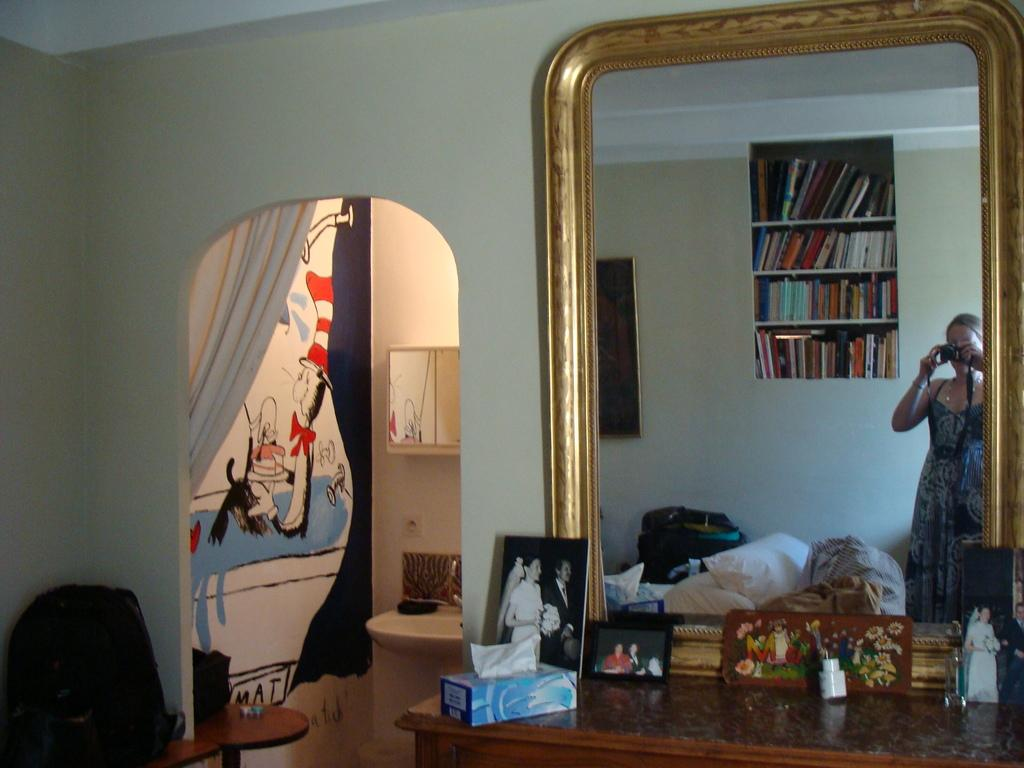What object in the image is reflective? There is a glass mirror in the image that reflects various objects. What can be seen in the mirror's reflection? The mirror reflects women, books, a wall, and cloth. What is the woman holding in the image? The woman is holding a camera. What item is present for cleaning or wiping? There is tissue in the image. What object is used for displaying photos? There is a photo frame in the image. Can you tell me how many patches are on the representative's suit in the image? There is no representative or suit present in the image; it features a glass mirror reflecting various objects and a woman holding a camera. 